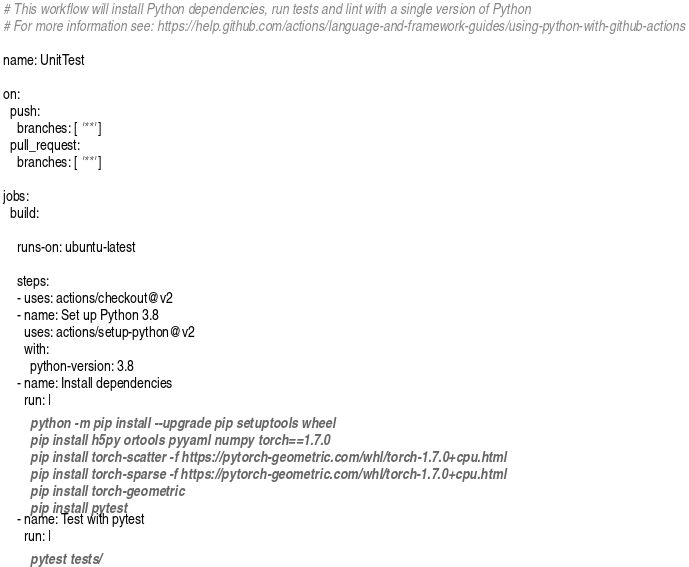<code> <loc_0><loc_0><loc_500><loc_500><_YAML_># This workflow will install Python dependencies, run tests and lint with a single version of Python
# For more information see: https://help.github.com/actions/language-and-framework-guides/using-python-with-github-actions

name: UnitTest

on:
  push:
    branches: [ '**' ]
  pull_request:
    branches: [ '**' ]

jobs:
  build:

    runs-on: ubuntu-latest

    steps:
    - uses: actions/checkout@v2
    - name: Set up Python 3.8
      uses: actions/setup-python@v2
      with:
        python-version: 3.8
    - name: Install dependencies
      run: |
        python -m pip install --upgrade pip setuptools wheel
        pip install h5py ortools pyyaml numpy torch==1.7.0
        pip install torch-scatter -f https://pytorch-geometric.com/whl/torch-1.7.0+cpu.html
        pip install torch-sparse -f https://pytorch-geometric.com/whl/torch-1.7.0+cpu.html
        pip install torch-geometric
        pip install pytest
    - name: Test with pytest
      run: |
        pytest tests/
</code> 